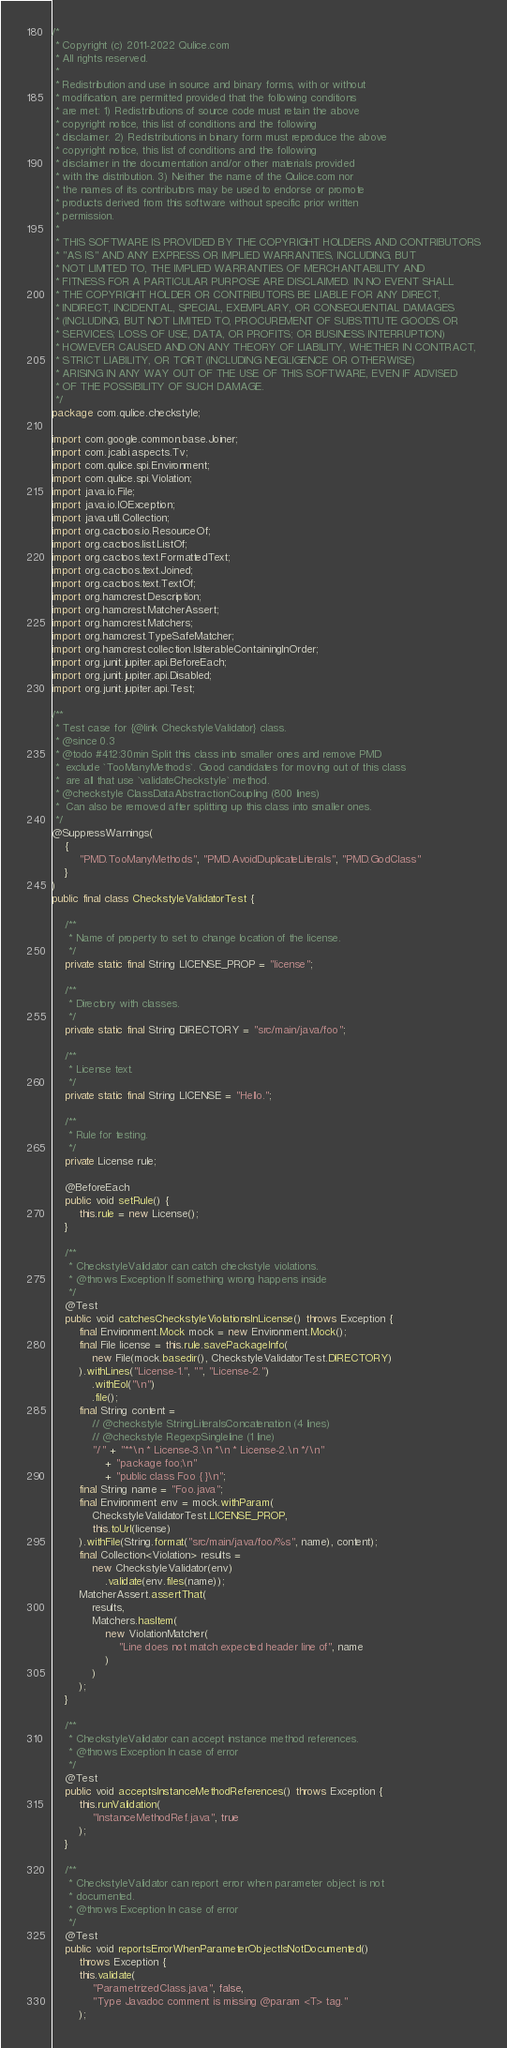Convert code to text. <code><loc_0><loc_0><loc_500><loc_500><_Java_>/*
 * Copyright (c) 2011-2022 Qulice.com
 * All rights reserved.
 *
 * Redistribution and use in source and binary forms, with or without
 * modification, are permitted provided that the following conditions
 * are met: 1) Redistributions of source code must retain the above
 * copyright notice, this list of conditions and the following
 * disclaimer. 2) Redistributions in binary form must reproduce the above
 * copyright notice, this list of conditions and the following
 * disclaimer in the documentation and/or other materials provided
 * with the distribution. 3) Neither the name of the Qulice.com nor
 * the names of its contributors may be used to endorse or promote
 * products derived from this software without specific prior written
 * permission.
 *
 * THIS SOFTWARE IS PROVIDED BY THE COPYRIGHT HOLDERS AND CONTRIBUTORS
 * "AS IS" AND ANY EXPRESS OR IMPLIED WARRANTIES, INCLUDING, BUT
 * NOT LIMITED TO, THE IMPLIED WARRANTIES OF MERCHANTABILITY AND
 * FITNESS FOR A PARTICULAR PURPOSE ARE DISCLAIMED. IN NO EVENT SHALL
 * THE COPYRIGHT HOLDER OR CONTRIBUTORS BE LIABLE FOR ANY DIRECT,
 * INDIRECT, INCIDENTAL, SPECIAL, EXEMPLARY, OR CONSEQUENTIAL DAMAGES
 * (INCLUDING, BUT NOT LIMITED TO, PROCUREMENT OF SUBSTITUTE GOODS OR
 * SERVICES; LOSS OF USE, DATA, OR PROFITS; OR BUSINESS INTERRUPTION)
 * HOWEVER CAUSED AND ON ANY THEORY OF LIABILITY, WHETHER IN CONTRACT,
 * STRICT LIABILITY, OR TORT (INCLUDING NEGLIGENCE OR OTHERWISE)
 * ARISING IN ANY WAY OUT OF THE USE OF THIS SOFTWARE, EVEN IF ADVISED
 * OF THE POSSIBILITY OF SUCH DAMAGE.
 */
package com.qulice.checkstyle;

import com.google.common.base.Joiner;
import com.jcabi.aspects.Tv;
import com.qulice.spi.Environment;
import com.qulice.spi.Violation;
import java.io.File;
import java.io.IOException;
import java.util.Collection;
import org.cactoos.io.ResourceOf;
import org.cactoos.list.ListOf;
import org.cactoos.text.FormattedText;
import org.cactoos.text.Joined;
import org.cactoos.text.TextOf;
import org.hamcrest.Description;
import org.hamcrest.MatcherAssert;
import org.hamcrest.Matchers;
import org.hamcrest.TypeSafeMatcher;
import org.hamcrest.collection.IsIterableContainingInOrder;
import org.junit.jupiter.api.BeforeEach;
import org.junit.jupiter.api.Disabled;
import org.junit.jupiter.api.Test;

/**
 * Test case for {@link CheckstyleValidator} class.
 * @since 0.3
 * @todo #412:30min Split this class into smaller ones and remove PMD
 *  exclude `TooManyMethods`. Good candidates for moving out of this class
 *  are all that use `validateCheckstyle` method.
 * @checkstyle ClassDataAbstractionCoupling (800 lines)
 *  Can also be removed after splitting up this class into smaller ones.
 */
@SuppressWarnings(
    {
        "PMD.TooManyMethods", "PMD.AvoidDuplicateLiterals", "PMD.GodClass"
    }
)
public final class CheckstyleValidatorTest {

    /**
     * Name of property to set to change location of the license.
     */
    private static final String LICENSE_PROP = "license";

    /**
     * Directory with classes.
     */
    private static final String DIRECTORY = "src/main/java/foo";

    /**
     * License text.
     */
    private static final String LICENSE = "Hello.";

    /**
     * Rule for testing.
     */
    private License rule;

    @BeforeEach
    public void setRule() {
        this.rule = new License();
    }

    /**
     * CheckstyleValidator can catch checkstyle violations.
     * @throws Exception If something wrong happens inside
     */
    @Test
    public void catchesCheckstyleViolationsInLicense() throws Exception {
        final Environment.Mock mock = new Environment.Mock();
        final File license = this.rule.savePackageInfo(
            new File(mock.basedir(), CheckstyleValidatorTest.DIRECTORY)
        ).withLines("License-1.", "", "License-2.")
            .withEol("\n")
            .file();
        final String content =
            // @checkstyle StringLiteralsConcatenation (4 lines)
            // @checkstyle RegexpSingleline (1 line)
            "/" + "**\n * License-3.\n *\n * License-2.\n */\n"
                + "package foo;\n"
                + "public class Foo { }\n";
        final String name = "Foo.java";
        final Environment env = mock.withParam(
            CheckstyleValidatorTest.LICENSE_PROP,
            this.toUrl(license)
        ).withFile(String.format("src/main/java/foo/%s", name), content);
        final Collection<Violation> results =
            new CheckstyleValidator(env)
                .validate(env.files(name));
        MatcherAssert.assertThat(
            results,
            Matchers.hasItem(
                new ViolationMatcher(
                    "Line does not match expected header line of", name
                )
            )
        );
    }

    /**
     * CheckstyleValidator can accept instance method references.
     * @throws Exception In case of error
     */
    @Test
    public void acceptsInstanceMethodReferences() throws Exception {
        this.runValidation(
            "InstanceMethodRef.java", true
        );
    }

    /**
     * CheckstyleValidator can report error when parameter object is not
     * documented.
     * @throws Exception In case of error
     */
    @Test
    public void reportsErrorWhenParameterObjectIsNotDocumented()
        throws Exception {
        this.validate(
            "ParametrizedClass.java", false,
            "Type Javadoc comment is missing @param <T> tag."
        );</code> 